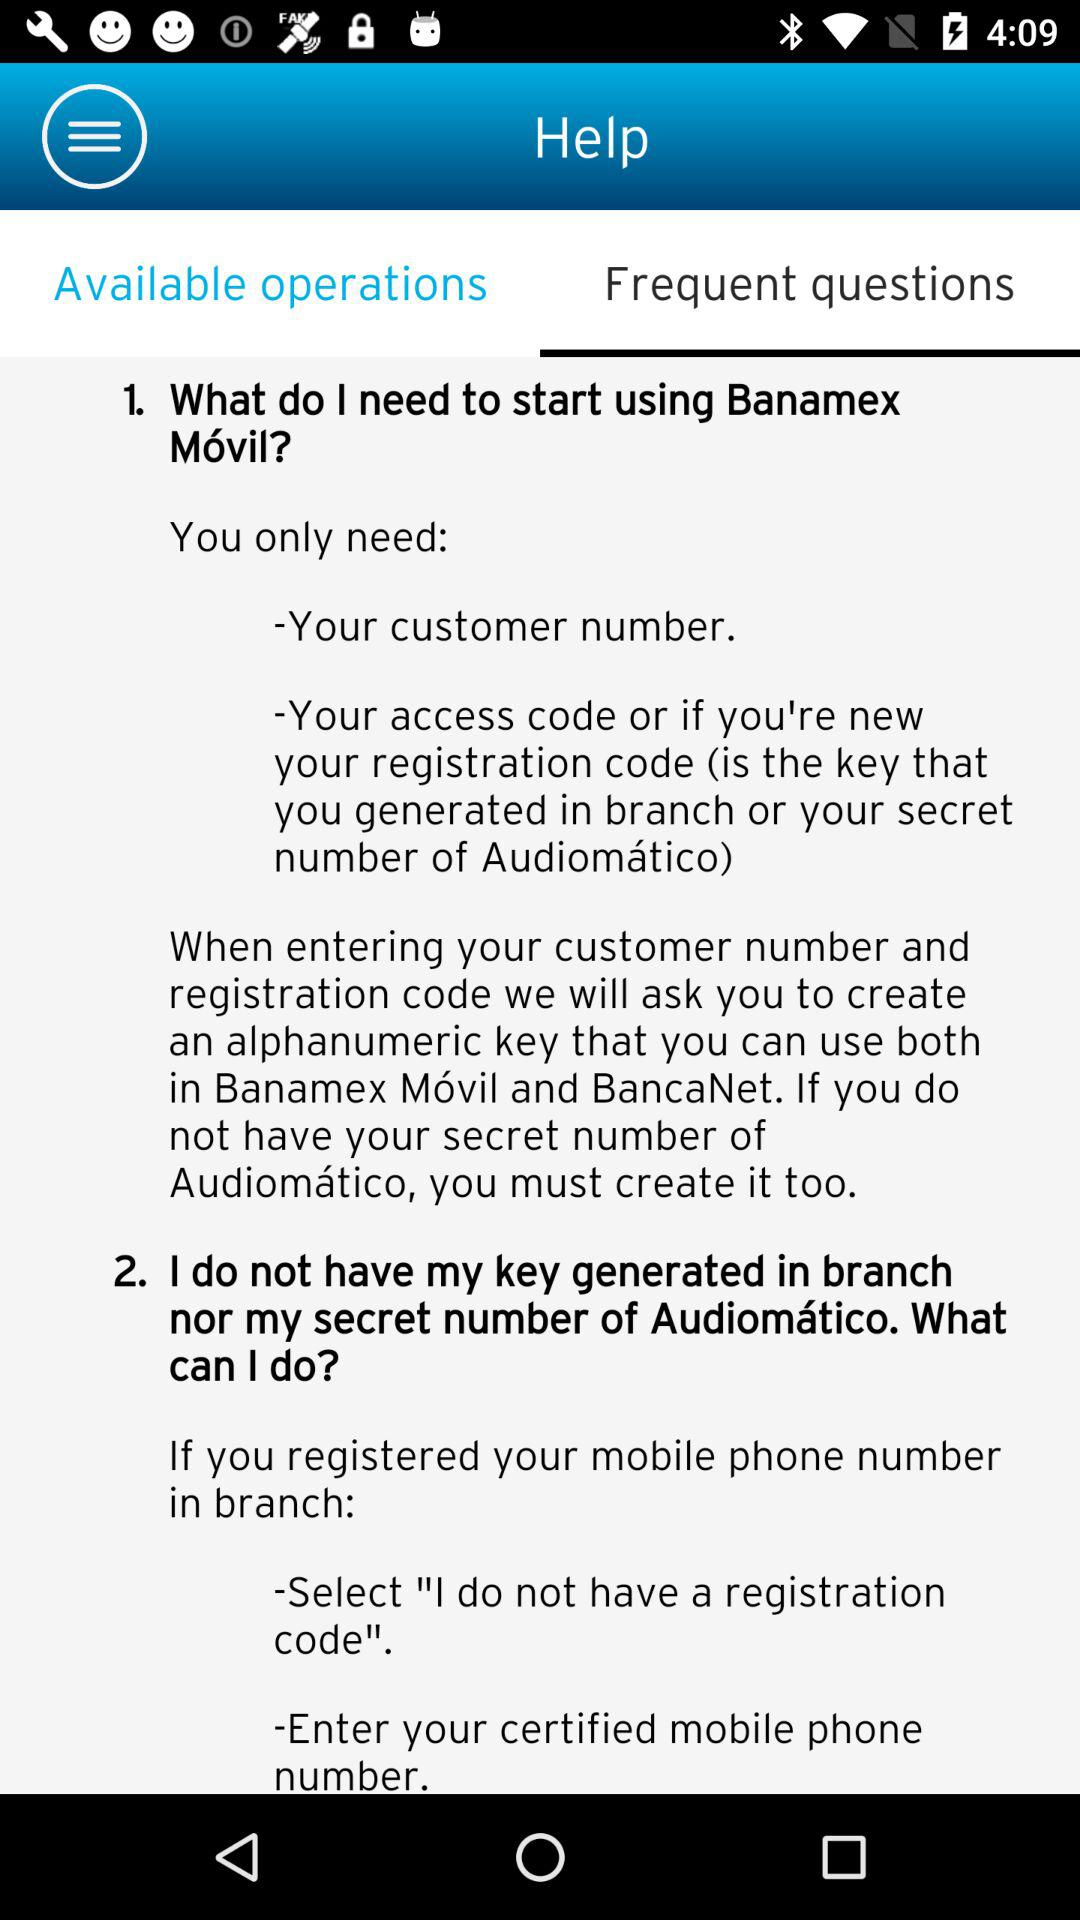Which tab is selected? The selected tab is "Frequent questions". 